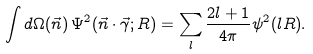<formula> <loc_0><loc_0><loc_500><loc_500>\int d \Omega ( \vec { n } ) \, \Psi ^ { 2 } ( \vec { n } \cdot \vec { \gamma } ; R ) = \sum _ { l } \frac { 2 l + 1 } { 4 \pi } \psi ^ { 2 } ( l R ) .</formula> 